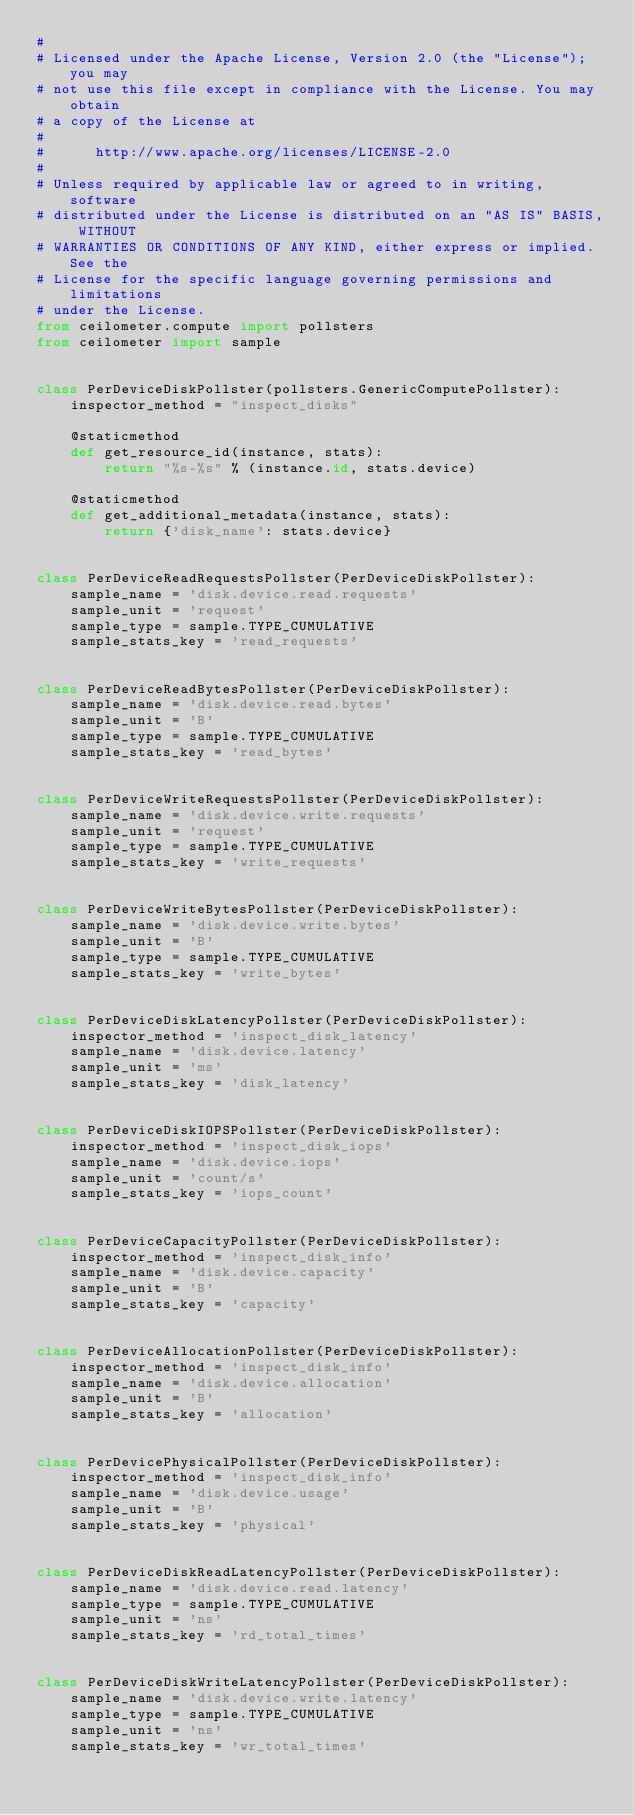Convert code to text. <code><loc_0><loc_0><loc_500><loc_500><_Python_>#
# Licensed under the Apache License, Version 2.0 (the "License"); you may
# not use this file except in compliance with the License. You may obtain
# a copy of the License at
#
#      http://www.apache.org/licenses/LICENSE-2.0
#
# Unless required by applicable law or agreed to in writing, software
# distributed under the License is distributed on an "AS IS" BASIS, WITHOUT
# WARRANTIES OR CONDITIONS OF ANY KIND, either express or implied. See the
# License for the specific language governing permissions and limitations
# under the License.
from ceilometer.compute import pollsters
from ceilometer import sample


class PerDeviceDiskPollster(pollsters.GenericComputePollster):
    inspector_method = "inspect_disks"

    @staticmethod
    def get_resource_id(instance, stats):
        return "%s-%s" % (instance.id, stats.device)

    @staticmethod
    def get_additional_metadata(instance, stats):
        return {'disk_name': stats.device}


class PerDeviceReadRequestsPollster(PerDeviceDiskPollster):
    sample_name = 'disk.device.read.requests'
    sample_unit = 'request'
    sample_type = sample.TYPE_CUMULATIVE
    sample_stats_key = 'read_requests'


class PerDeviceReadBytesPollster(PerDeviceDiskPollster):
    sample_name = 'disk.device.read.bytes'
    sample_unit = 'B'
    sample_type = sample.TYPE_CUMULATIVE
    sample_stats_key = 'read_bytes'


class PerDeviceWriteRequestsPollster(PerDeviceDiskPollster):
    sample_name = 'disk.device.write.requests'
    sample_unit = 'request'
    sample_type = sample.TYPE_CUMULATIVE
    sample_stats_key = 'write_requests'


class PerDeviceWriteBytesPollster(PerDeviceDiskPollster):
    sample_name = 'disk.device.write.bytes'
    sample_unit = 'B'
    sample_type = sample.TYPE_CUMULATIVE
    sample_stats_key = 'write_bytes'


class PerDeviceDiskLatencyPollster(PerDeviceDiskPollster):
    inspector_method = 'inspect_disk_latency'
    sample_name = 'disk.device.latency'
    sample_unit = 'ms'
    sample_stats_key = 'disk_latency'


class PerDeviceDiskIOPSPollster(PerDeviceDiskPollster):
    inspector_method = 'inspect_disk_iops'
    sample_name = 'disk.device.iops'
    sample_unit = 'count/s'
    sample_stats_key = 'iops_count'


class PerDeviceCapacityPollster(PerDeviceDiskPollster):
    inspector_method = 'inspect_disk_info'
    sample_name = 'disk.device.capacity'
    sample_unit = 'B'
    sample_stats_key = 'capacity'


class PerDeviceAllocationPollster(PerDeviceDiskPollster):
    inspector_method = 'inspect_disk_info'
    sample_name = 'disk.device.allocation'
    sample_unit = 'B'
    sample_stats_key = 'allocation'


class PerDevicePhysicalPollster(PerDeviceDiskPollster):
    inspector_method = 'inspect_disk_info'
    sample_name = 'disk.device.usage'
    sample_unit = 'B'
    sample_stats_key = 'physical'


class PerDeviceDiskReadLatencyPollster(PerDeviceDiskPollster):
    sample_name = 'disk.device.read.latency'
    sample_type = sample.TYPE_CUMULATIVE
    sample_unit = 'ns'
    sample_stats_key = 'rd_total_times'


class PerDeviceDiskWriteLatencyPollster(PerDeviceDiskPollster):
    sample_name = 'disk.device.write.latency'
    sample_type = sample.TYPE_CUMULATIVE
    sample_unit = 'ns'
    sample_stats_key = 'wr_total_times'
</code> 